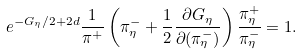<formula> <loc_0><loc_0><loc_500><loc_500>e ^ { - G _ { \eta } / 2 + 2 d } \frac { 1 } { \pi ^ { + } } \left ( \pi ^ { - } _ { \eta } + \frac { 1 } { 2 } \frac { \partial G _ { \eta } } { \partial ( \pi ^ { - } _ { \eta } ) } \right ) \frac { \pi ^ { + } _ { \eta } } { \pi ^ { - } _ { \eta } } = 1 .</formula> 